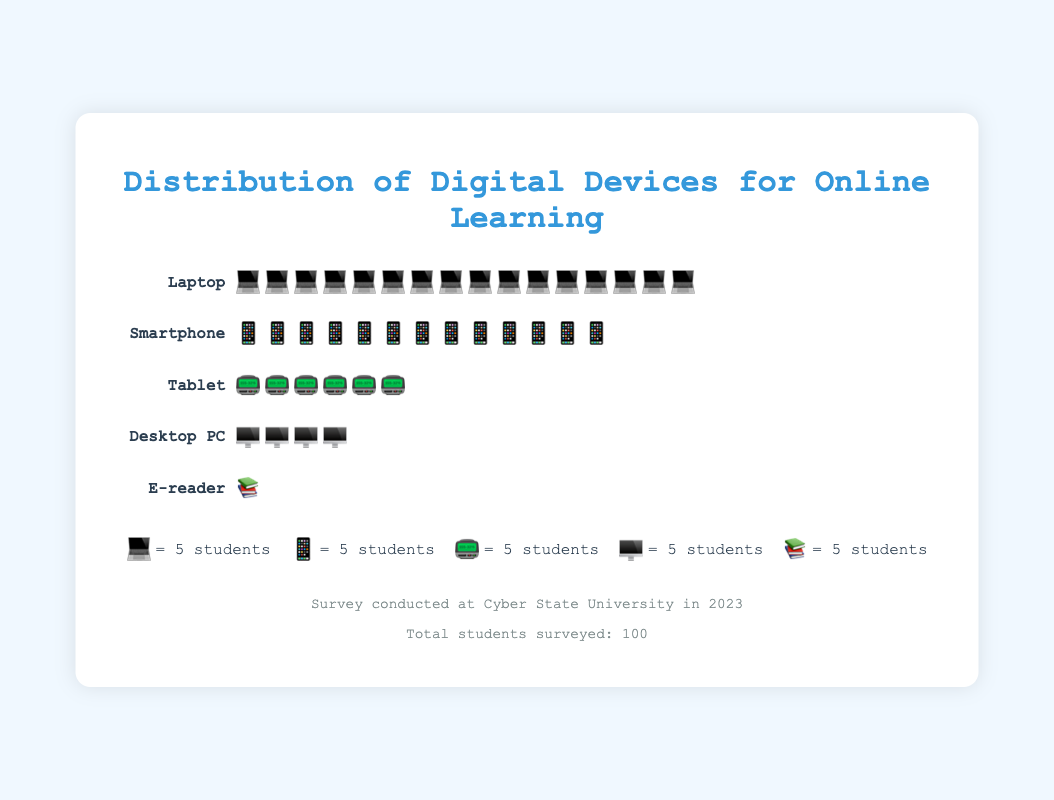What's the title of the figure? The title of the figure is located at the top and clearly states the main topic being visualized.
Answer: Distribution of Digital Devices for Online Learning How many types of digital devices are shown in the plot? To determine the number of different devices, count the unique device names listed on the left.
Answer: 5 Which device is used by the highest number of students? By examining the number of icons for each device row, the device with the largest number of icons is the most used.
Answer: Laptop How many students use E-readers for online learning? The number of E-readers can be directly counted by the single icon present in its row, and considering the legend where each icon represents 5 students.
Answer: 5 What percentage of students use smartphones for online learning? Calculate the percentage by dividing the number of students using smartphones (65) by the total number of students (100) and multiplying by 100.
Answer: 65% What is the total number of students using laptops and smartphones combined? Add the number of students using laptops (80) to those using smartphones (65).
Answer: 145 How many more students use laptops compared to desktops? Subtract the number of desktop users (20) from the number of laptop users (80).
Answer: 60 Rank the devices from most used to least used. List the devices in descending order based on the count of students using each.
Answer: Laptop, Smartphone, Tablet, Desktop PC, E-reader How many devices have a user count that is less than 50 students? Identify devices with user counts below 50 and count them.
Answer: 3 Based on the isotype plot, which devices are used by an equal number of students? Compare the number of icons in each row to identify devices used by the same number of students.
Answer: No devices are used by an equal number of students 